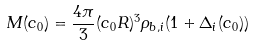<formula> <loc_0><loc_0><loc_500><loc_500>M ( c _ { 0 } ) = \frac { 4 \pi } { 3 } ( c _ { 0 } R ) ^ { 3 } \rho _ { b , i } ( 1 + \Delta _ { i } ( c _ { 0 } ) )</formula> 